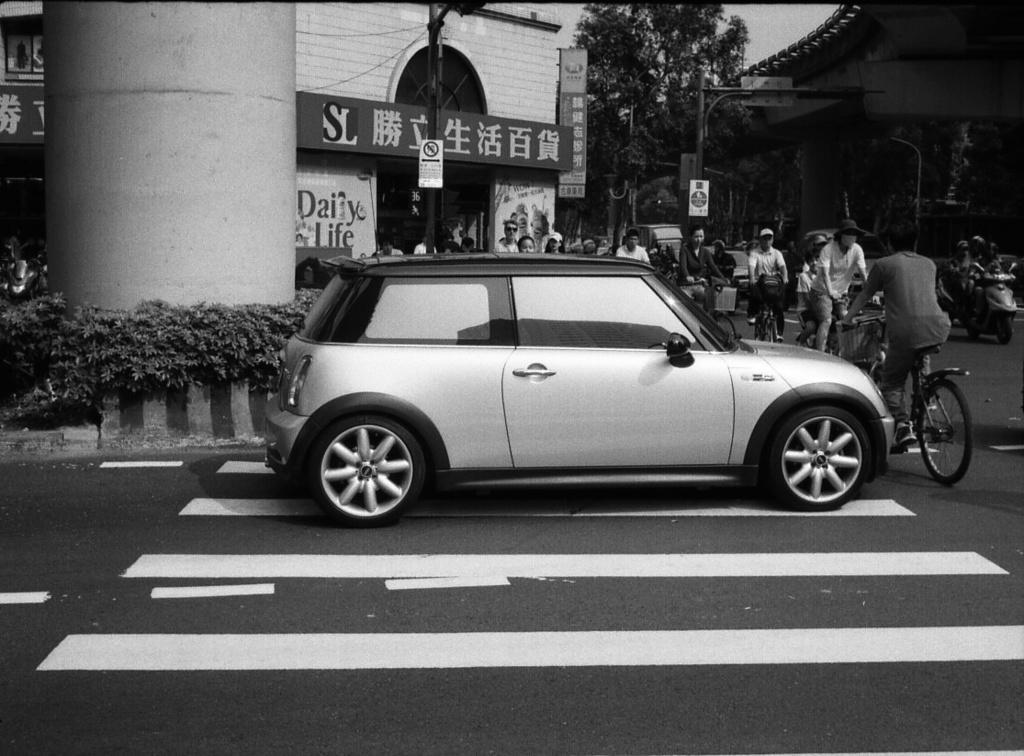Describe this image in one or two sentences. In the picture we can see a street, we can see a road, car, pillar, flyover, and shops and some people are riding a bicycles. 